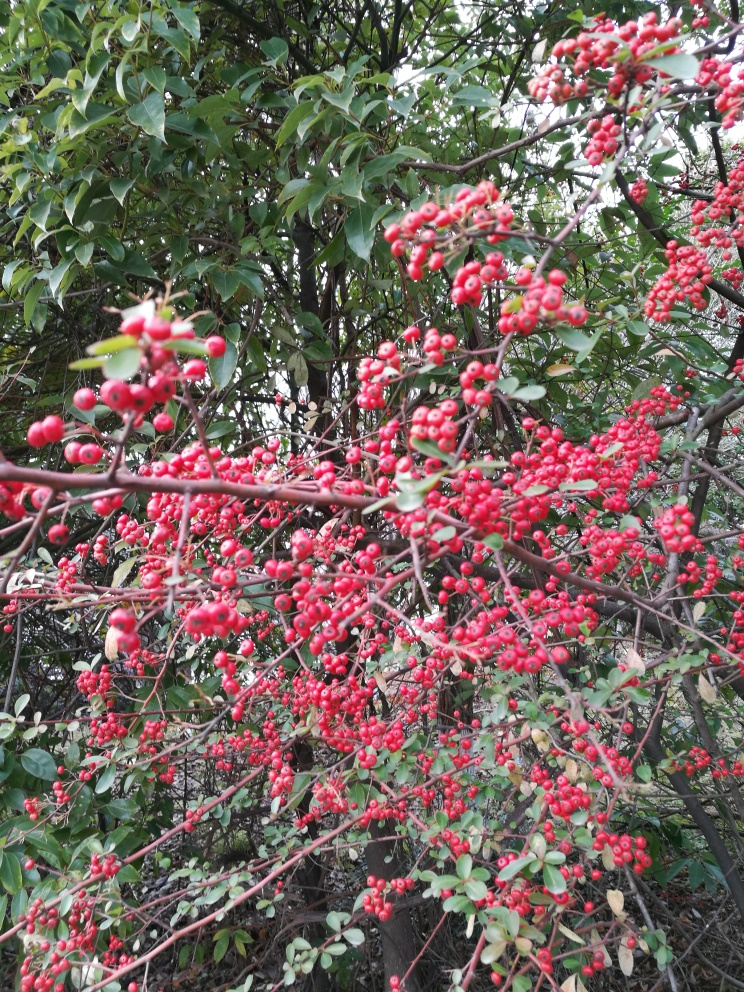What kind of plant is this? This appears to be a type of shrub rich with clusters of red berries, often associated with species in the family Rosaceae. It may be a Cotoneaster, Pyracantha, or a similar berry-producing plant. Is this plant common in certain areas or climates? Yes, these berry-producing shrubs are often found in temperate zones. They are commonly used for landscaping due to their striking appearance and are known to attract birds and other wildlife. 